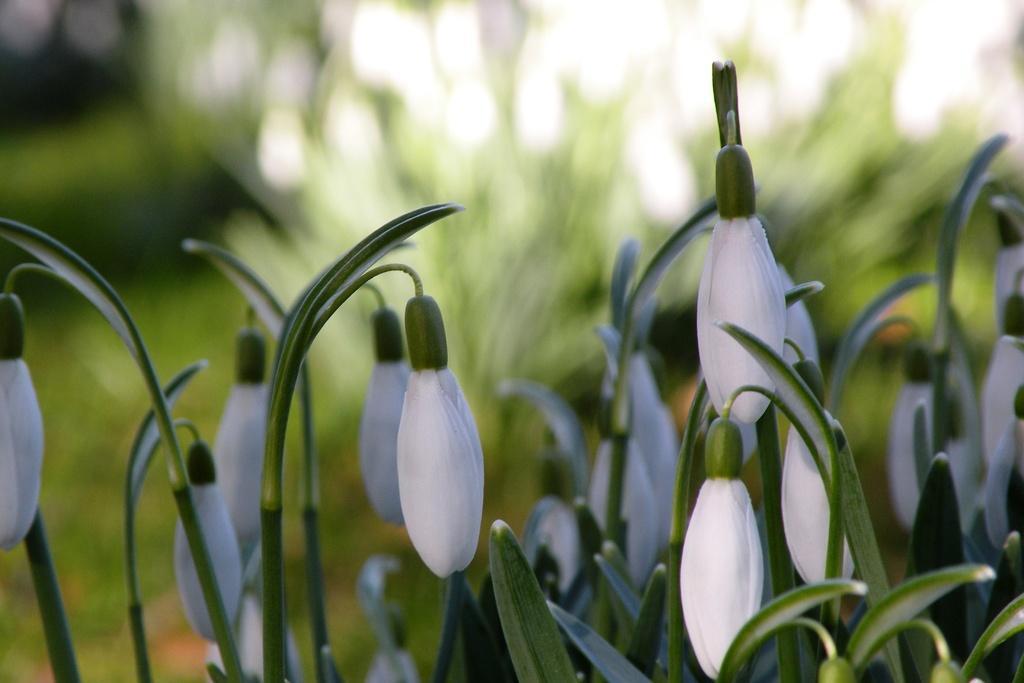How would you summarize this image in a sentence or two? In the image there are many leucojum plants,there are beautiful white flowers to the plants and the background is blurred. 